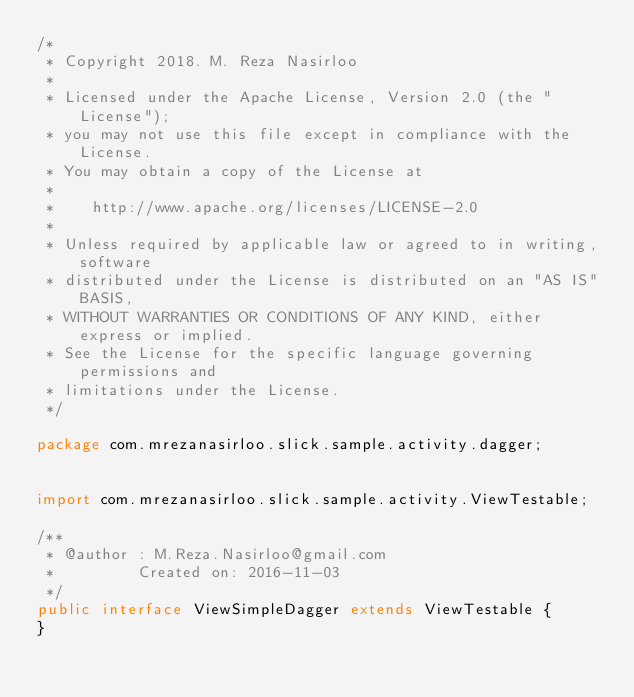Convert code to text. <code><loc_0><loc_0><loc_500><loc_500><_Java_>/*
 * Copyright 2018. M. Reza Nasirloo
 *
 * Licensed under the Apache License, Version 2.0 (the "License");
 * you may not use this file except in compliance with the License.
 * You may obtain a copy of the License at
 *
 *    http://www.apache.org/licenses/LICENSE-2.0
 *
 * Unless required by applicable law or agreed to in writing, software
 * distributed under the License is distributed on an "AS IS" BASIS,
 * WITHOUT WARRANTIES OR CONDITIONS OF ANY KIND, either express or implied.
 * See the License for the specific language governing permissions and
 * limitations under the License.
 */

package com.mrezanasirloo.slick.sample.activity.dagger;


import com.mrezanasirloo.slick.sample.activity.ViewTestable;

/**
 * @author : M.Reza.Nasirloo@gmail.com
 *         Created on: 2016-11-03
 */
public interface ViewSimpleDagger extends ViewTestable {
}
</code> 